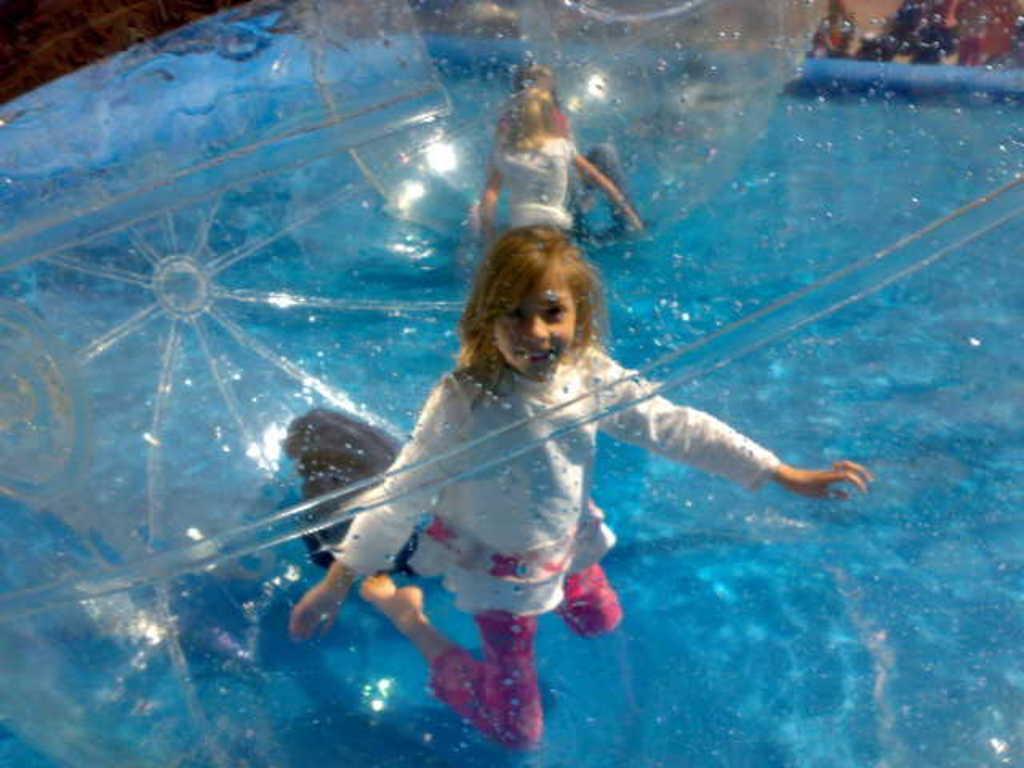Can you describe this image briefly? There are kids and inflatable balls are present on the surface of water. 